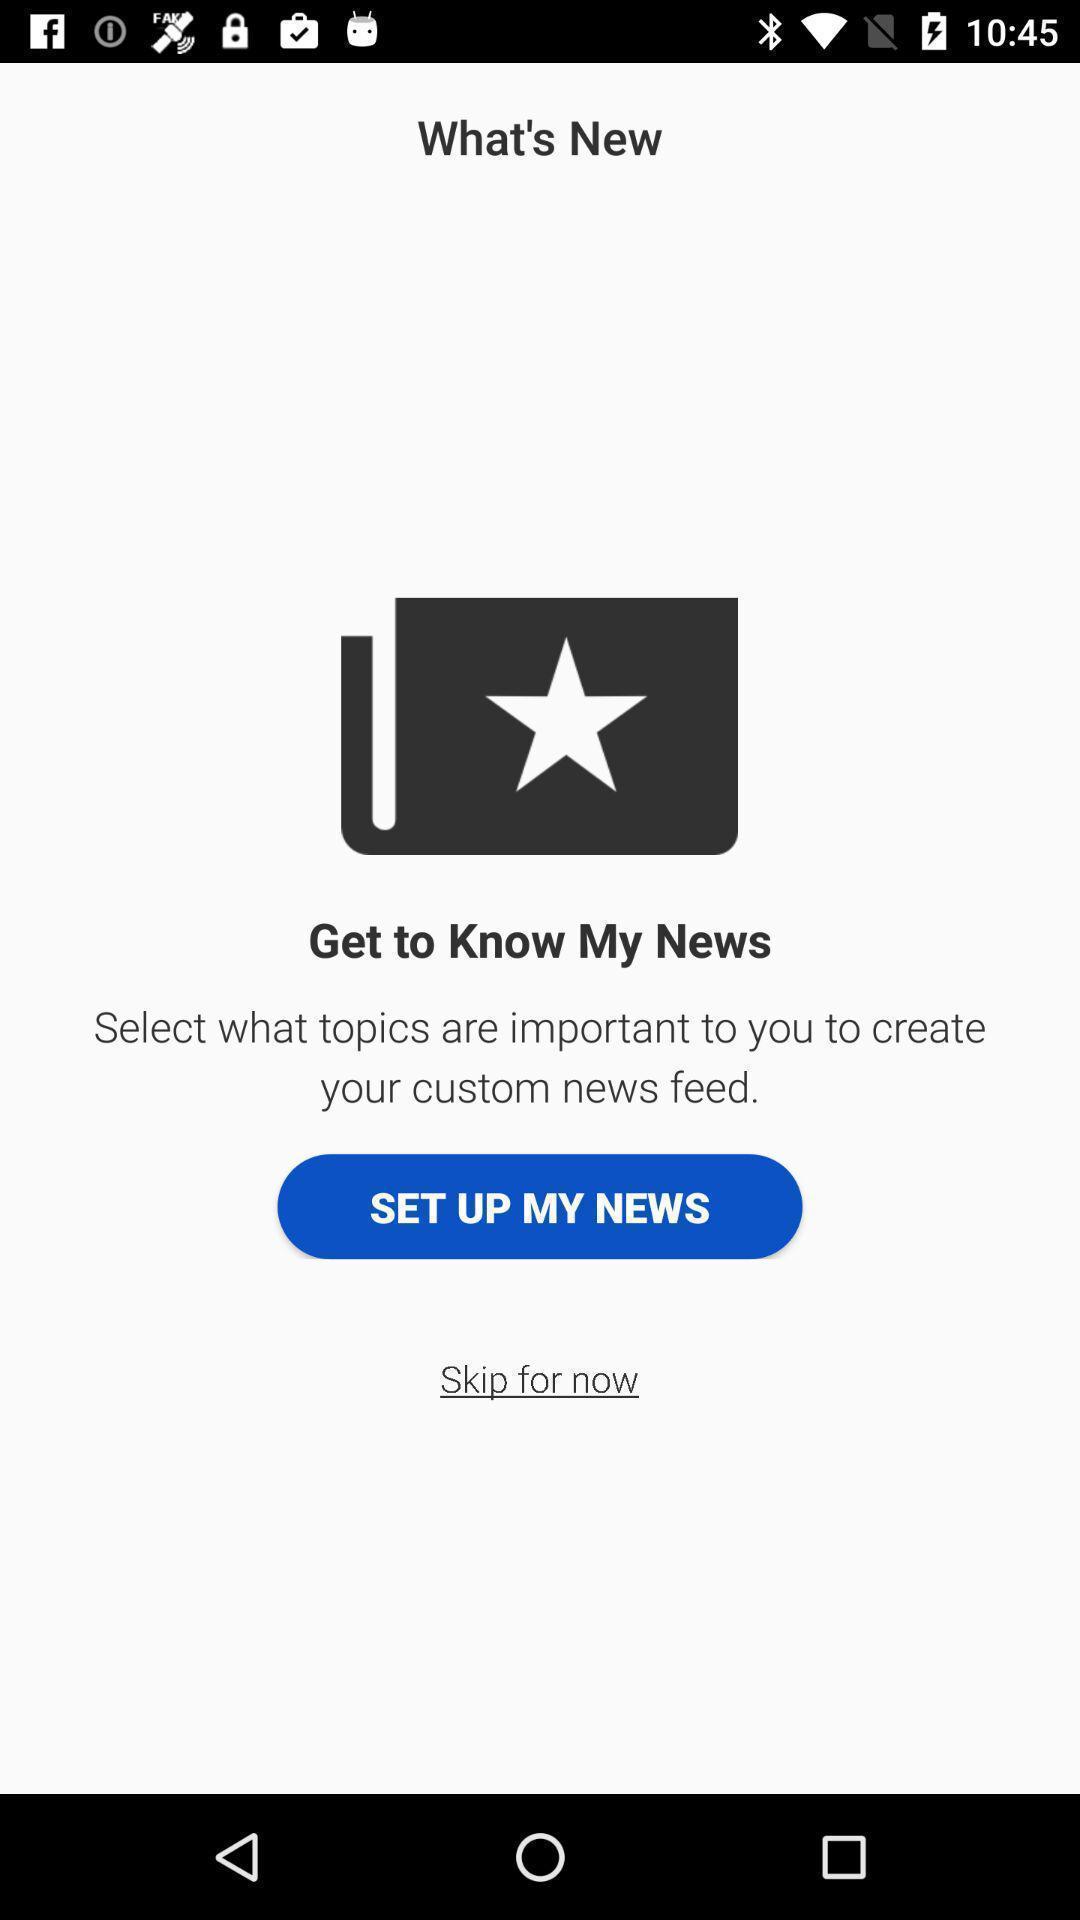Give me a narrative description of this picture. Page showing to set up. 